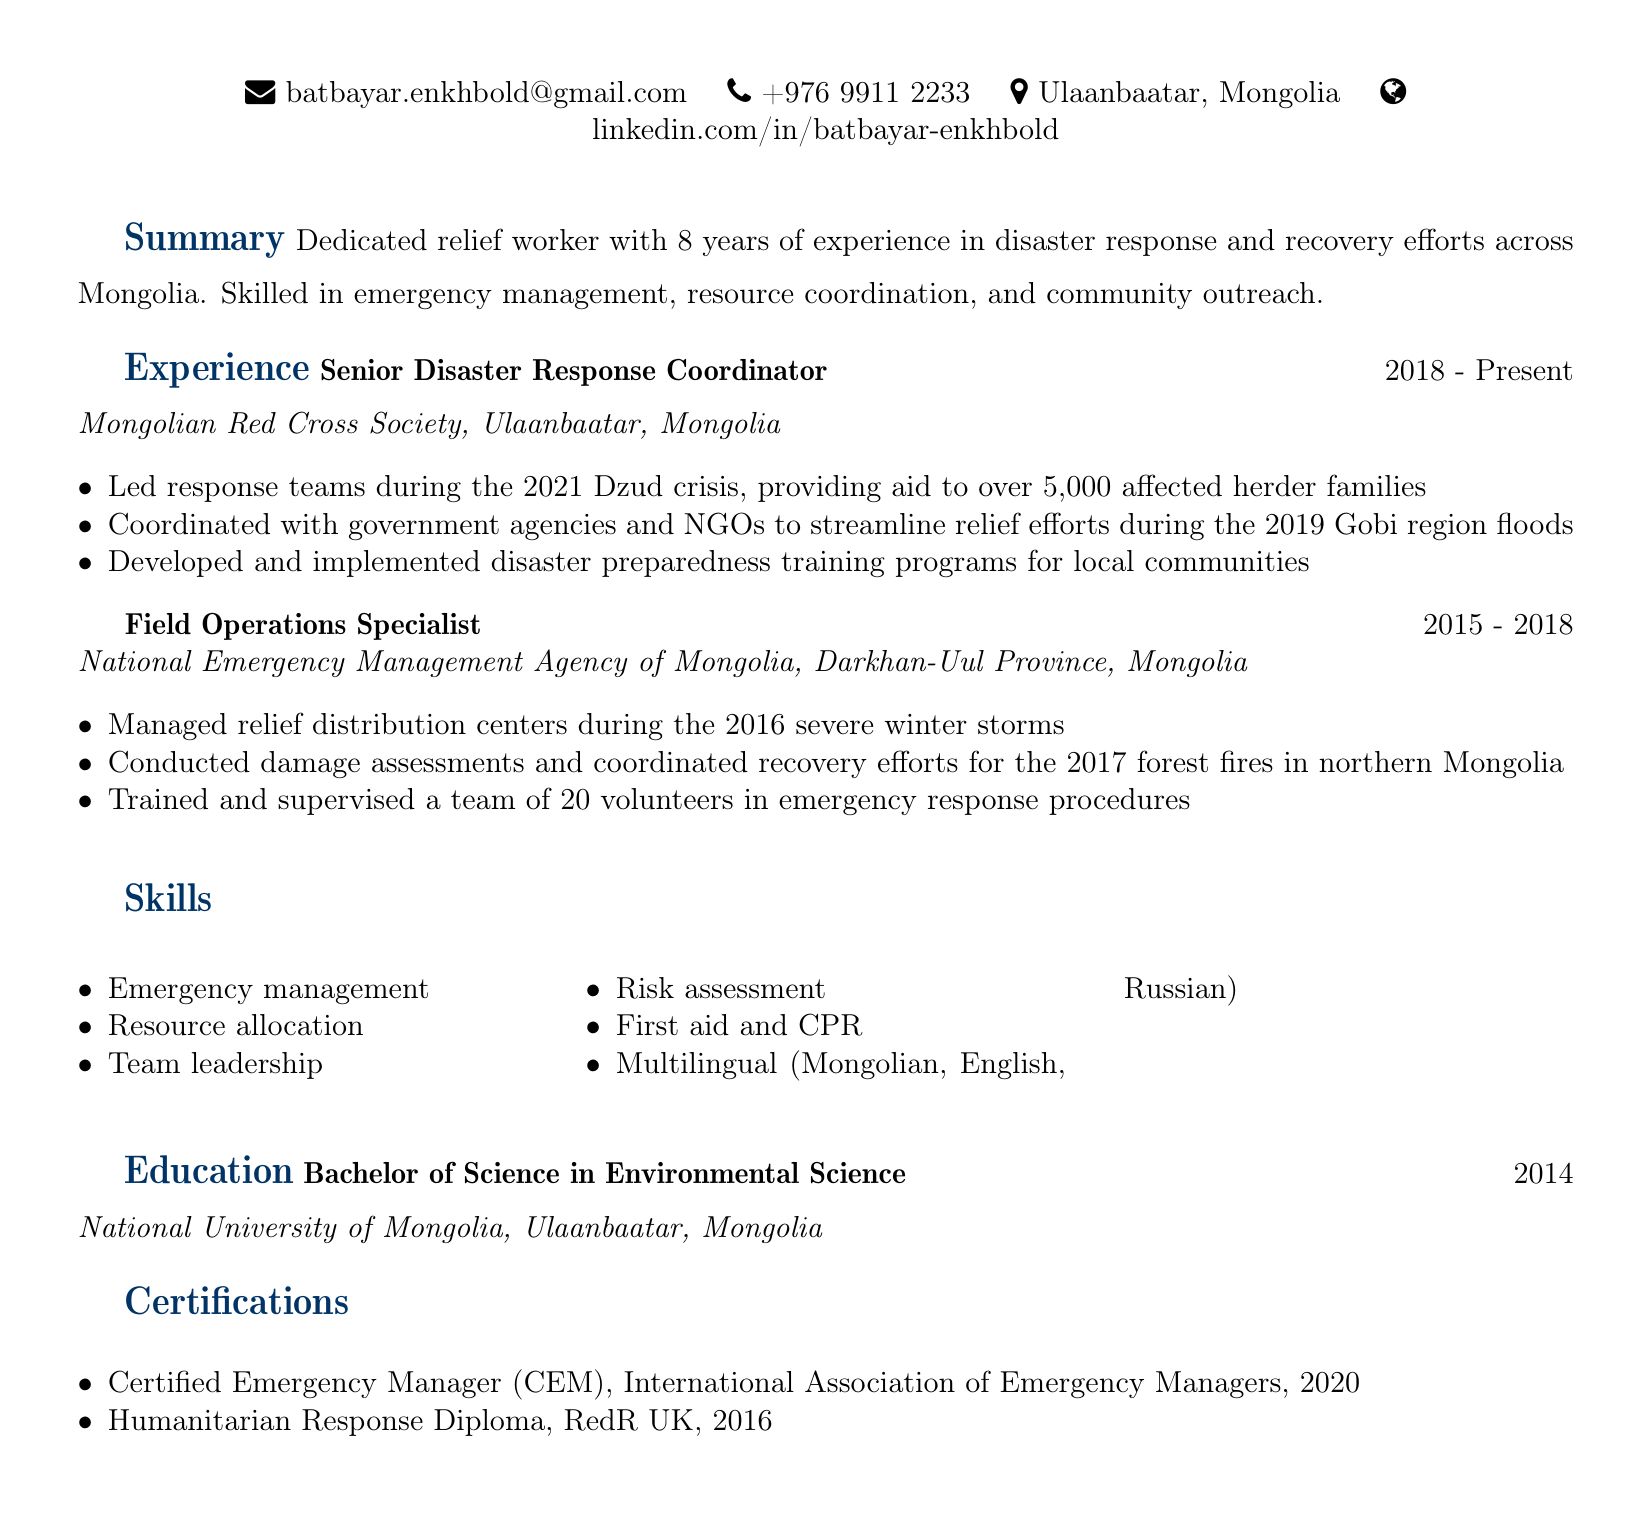What is Batbayar's email address? Batbayar's email address is listed under personal information in the document.
Answer: batbayar.enkhbold@gmail.com What organization does Batbayar work for currently? The current organization Batbayar is working for is mentioned in the experience section of the document.
Answer: Mongolian Red Cross Society In which year did Batbayar graduate? The graduation year is stated in the education section of the document.
Answer: 2014 How many years of experience does Batbayar have in disaster response? The total years of experience are summarized in the document's summary section.
Answer: 8 years What role did Batbayar have from 2015 to 2018? The specific role held during that time is outlined in the experience section.
Answer: Field Operations Specialist How many families received aid during the 2021 Dzud crisis? The number of families is specified in the responsibilities listed under Batbayar's current position.
Answer: over 5,000 Which certification did Batbayar obtain in 2020? The certification is listed in the certifications section of the document.
Answer: Certified Emergency Manager (CEM) What is one of Batbayar’s skills? The skills section contains various abilities, among which one can be chosen.
Answer: Emergency management 